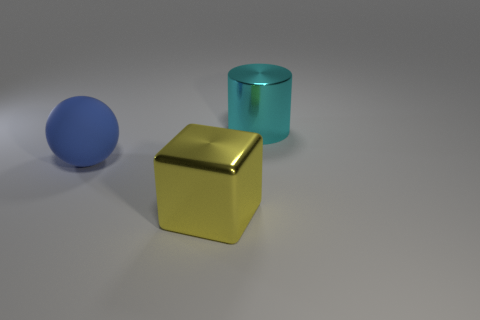Are there any other things that have the same material as the blue object?
Offer a very short reply. No. Are there an equal number of shiny cylinders that are to the left of the large matte ball and green shiny cylinders?
Give a very brief answer. Yes. Are there any large blue rubber spheres that are in front of the big thing that is on the right side of the large metal thing to the left of the cyan thing?
Give a very brief answer. Yes. What is the material of the yellow object?
Give a very brief answer. Metal. What number of other objects are there of the same shape as the cyan shiny object?
Provide a short and direct response. 0. How many things are big objects that are to the left of the cyan thing or large things that are in front of the large matte thing?
Provide a short and direct response. 2. What number of things are big metal things or cyan objects?
Make the answer very short. 2. What number of matte objects are to the right of the large metal thing that is in front of the metallic cylinder?
Provide a succinct answer. 0. How many other things are the same size as the ball?
Ensure brevity in your answer.  2. What is the material of the large cylinder behind the big yellow shiny block?
Offer a very short reply. Metal. 